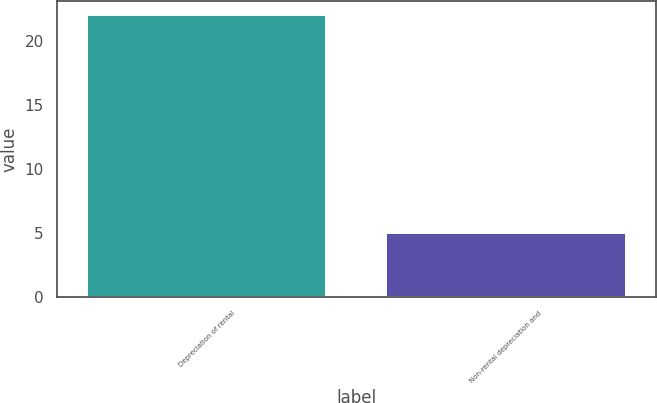Convert chart to OTSL. <chart><loc_0><loc_0><loc_500><loc_500><bar_chart><fcel>Depreciation of rental<fcel>Non-rental depreciation and<nl><fcel>22<fcel>5<nl></chart> 